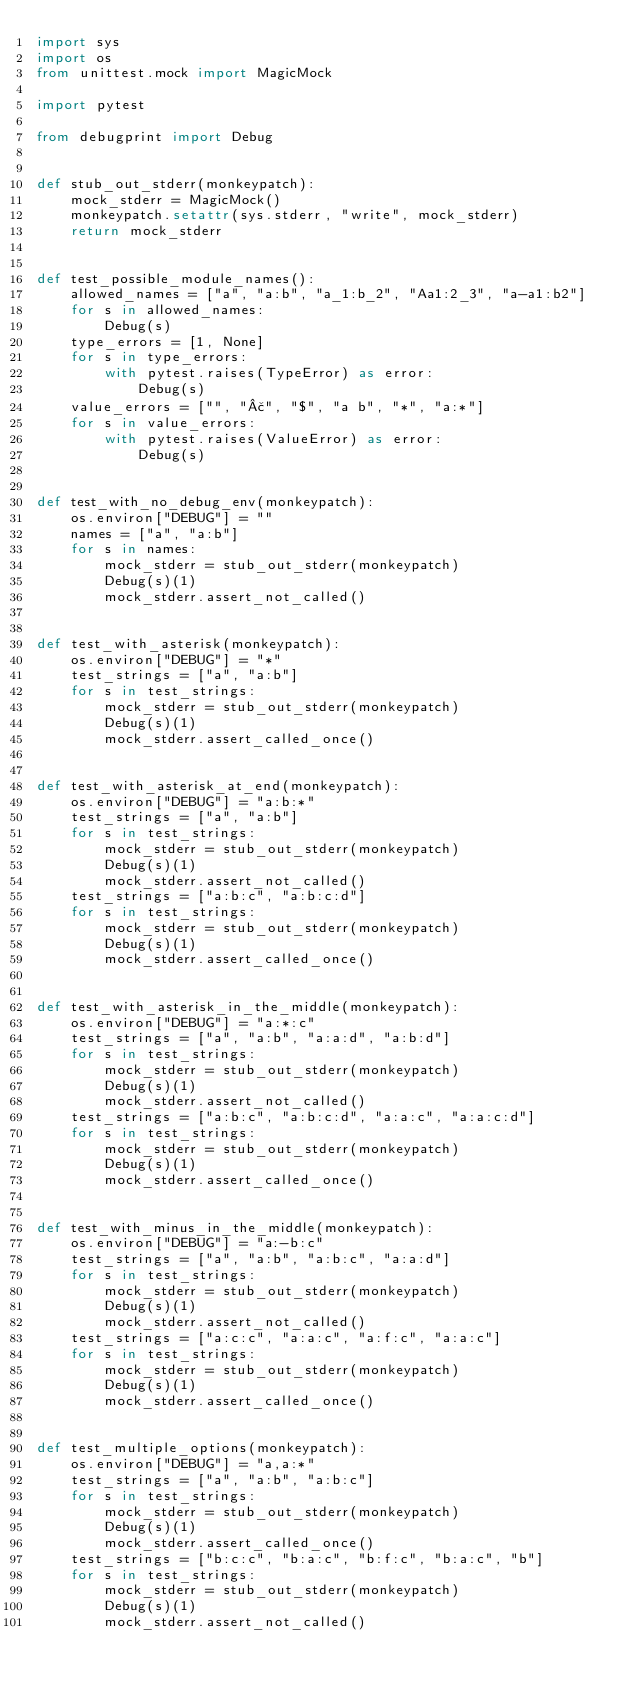<code> <loc_0><loc_0><loc_500><loc_500><_Python_>import sys
import os
from unittest.mock import MagicMock

import pytest

from debugprint import Debug


def stub_out_stderr(monkeypatch):
    mock_stderr = MagicMock()
    monkeypatch.setattr(sys.stderr, "write", mock_stderr)
    return mock_stderr


def test_possible_module_names():
    allowed_names = ["a", "a:b", "a_1:b_2", "Aa1:2_3", "a-a1:b2"]
    for s in allowed_names:
        Debug(s)
    type_errors = [1, None]
    for s in type_errors:
        with pytest.raises(TypeError) as error:
            Debug(s)
    value_errors = ["", "£", "$", "a b", "*", "a:*"]
    for s in value_errors:
        with pytest.raises(ValueError) as error:
            Debug(s)


def test_with_no_debug_env(monkeypatch):
    os.environ["DEBUG"] = ""
    names = ["a", "a:b"]
    for s in names:
        mock_stderr = stub_out_stderr(monkeypatch)
        Debug(s)(1)
        mock_stderr.assert_not_called()


def test_with_asterisk(monkeypatch):
    os.environ["DEBUG"] = "*"
    test_strings = ["a", "a:b"]
    for s in test_strings:
        mock_stderr = stub_out_stderr(monkeypatch)
        Debug(s)(1)
        mock_stderr.assert_called_once()


def test_with_asterisk_at_end(monkeypatch):
    os.environ["DEBUG"] = "a:b:*"
    test_strings = ["a", "a:b"]
    for s in test_strings:
        mock_stderr = stub_out_stderr(monkeypatch)
        Debug(s)(1)
        mock_stderr.assert_not_called()
    test_strings = ["a:b:c", "a:b:c:d"]
    for s in test_strings:
        mock_stderr = stub_out_stderr(monkeypatch)
        Debug(s)(1)
        mock_stderr.assert_called_once()


def test_with_asterisk_in_the_middle(monkeypatch):
    os.environ["DEBUG"] = "a:*:c"
    test_strings = ["a", "a:b", "a:a:d", "a:b:d"]
    for s in test_strings:
        mock_stderr = stub_out_stderr(monkeypatch)
        Debug(s)(1)
        mock_stderr.assert_not_called()
    test_strings = ["a:b:c", "a:b:c:d", "a:a:c", "a:a:c:d"]
    for s in test_strings:
        mock_stderr = stub_out_stderr(monkeypatch)
        Debug(s)(1)
        mock_stderr.assert_called_once()


def test_with_minus_in_the_middle(monkeypatch):
    os.environ["DEBUG"] = "a:-b:c"
    test_strings = ["a", "a:b", "a:b:c", "a:a:d"]
    for s in test_strings:
        mock_stderr = stub_out_stderr(monkeypatch)
        Debug(s)(1)
        mock_stderr.assert_not_called()
    test_strings = ["a:c:c", "a:a:c", "a:f:c", "a:a:c"]
    for s in test_strings:
        mock_stderr = stub_out_stderr(monkeypatch)
        Debug(s)(1)
        mock_stderr.assert_called_once()


def test_multiple_options(monkeypatch):
    os.environ["DEBUG"] = "a,a:*"
    test_strings = ["a", "a:b", "a:b:c"]
    for s in test_strings:
        mock_stderr = stub_out_stderr(monkeypatch)
        Debug(s)(1)
        mock_stderr.assert_called_once()
    test_strings = ["b:c:c", "b:a:c", "b:f:c", "b:a:c", "b"]
    for s in test_strings:
        mock_stderr = stub_out_stderr(monkeypatch)
        Debug(s)(1)
        mock_stderr.assert_not_called()
</code> 